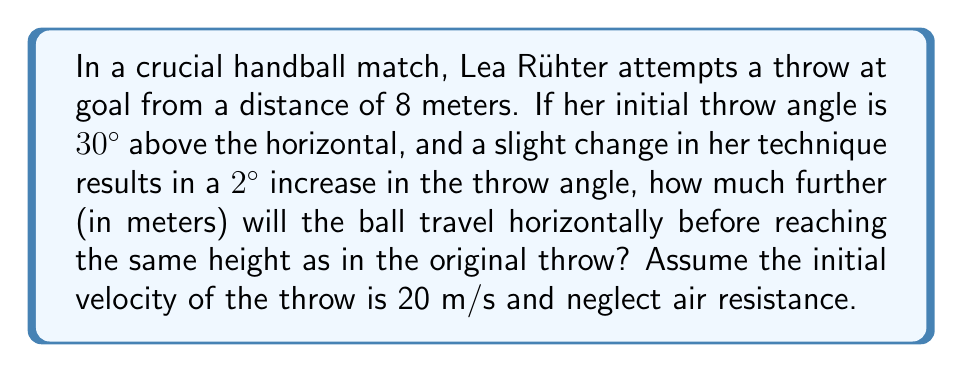What is the answer to this math problem? Let's approach this step-by-step:

1) First, we need to calculate the time it takes for the ball to reach its maximum height in both cases. We can use the equation:

   $$t = \frac{v_0 \sin \theta}{g}$$

   where $v_0$ is the initial velocity, $\theta$ is the angle, and $g$ is the acceleration due to gravity (9.8 m/s²).

2) For the original throw (30°):
   $$t_1 = \frac{20 \sin 30°}{9.8} = 1.02 \text{ s}$$

3) For the modified throw (32°):
   $$t_2 = \frac{20 \sin 32°}{9.8} = 1.08 \text{ s}$$

4) Now, we can calculate the horizontal distance traveled in each case using:

   $$x = v_0 \cos \theta \cdot t$$

5) For the original throw:
   $$x_1 = 20 \cos 30° \cdot 1.02 = 17.66 \text{ m}$$

6) For the modified throw:
   $$x_2 = 20 \cos 32° \cdot 1.08 = 18.31 \text{ m}$$

7) The difference in horizontal distance is:
   $$\Delta x = x_2 - x_1 = 18.31 - 17.66 = 0.65 \text{ m}$$

This demonstrates the butterfly effect in handball, where a small change in the throw angle (just 2°) results in a significant difference in the ball's trajectory and landing point.
Answer: 0.65 m 